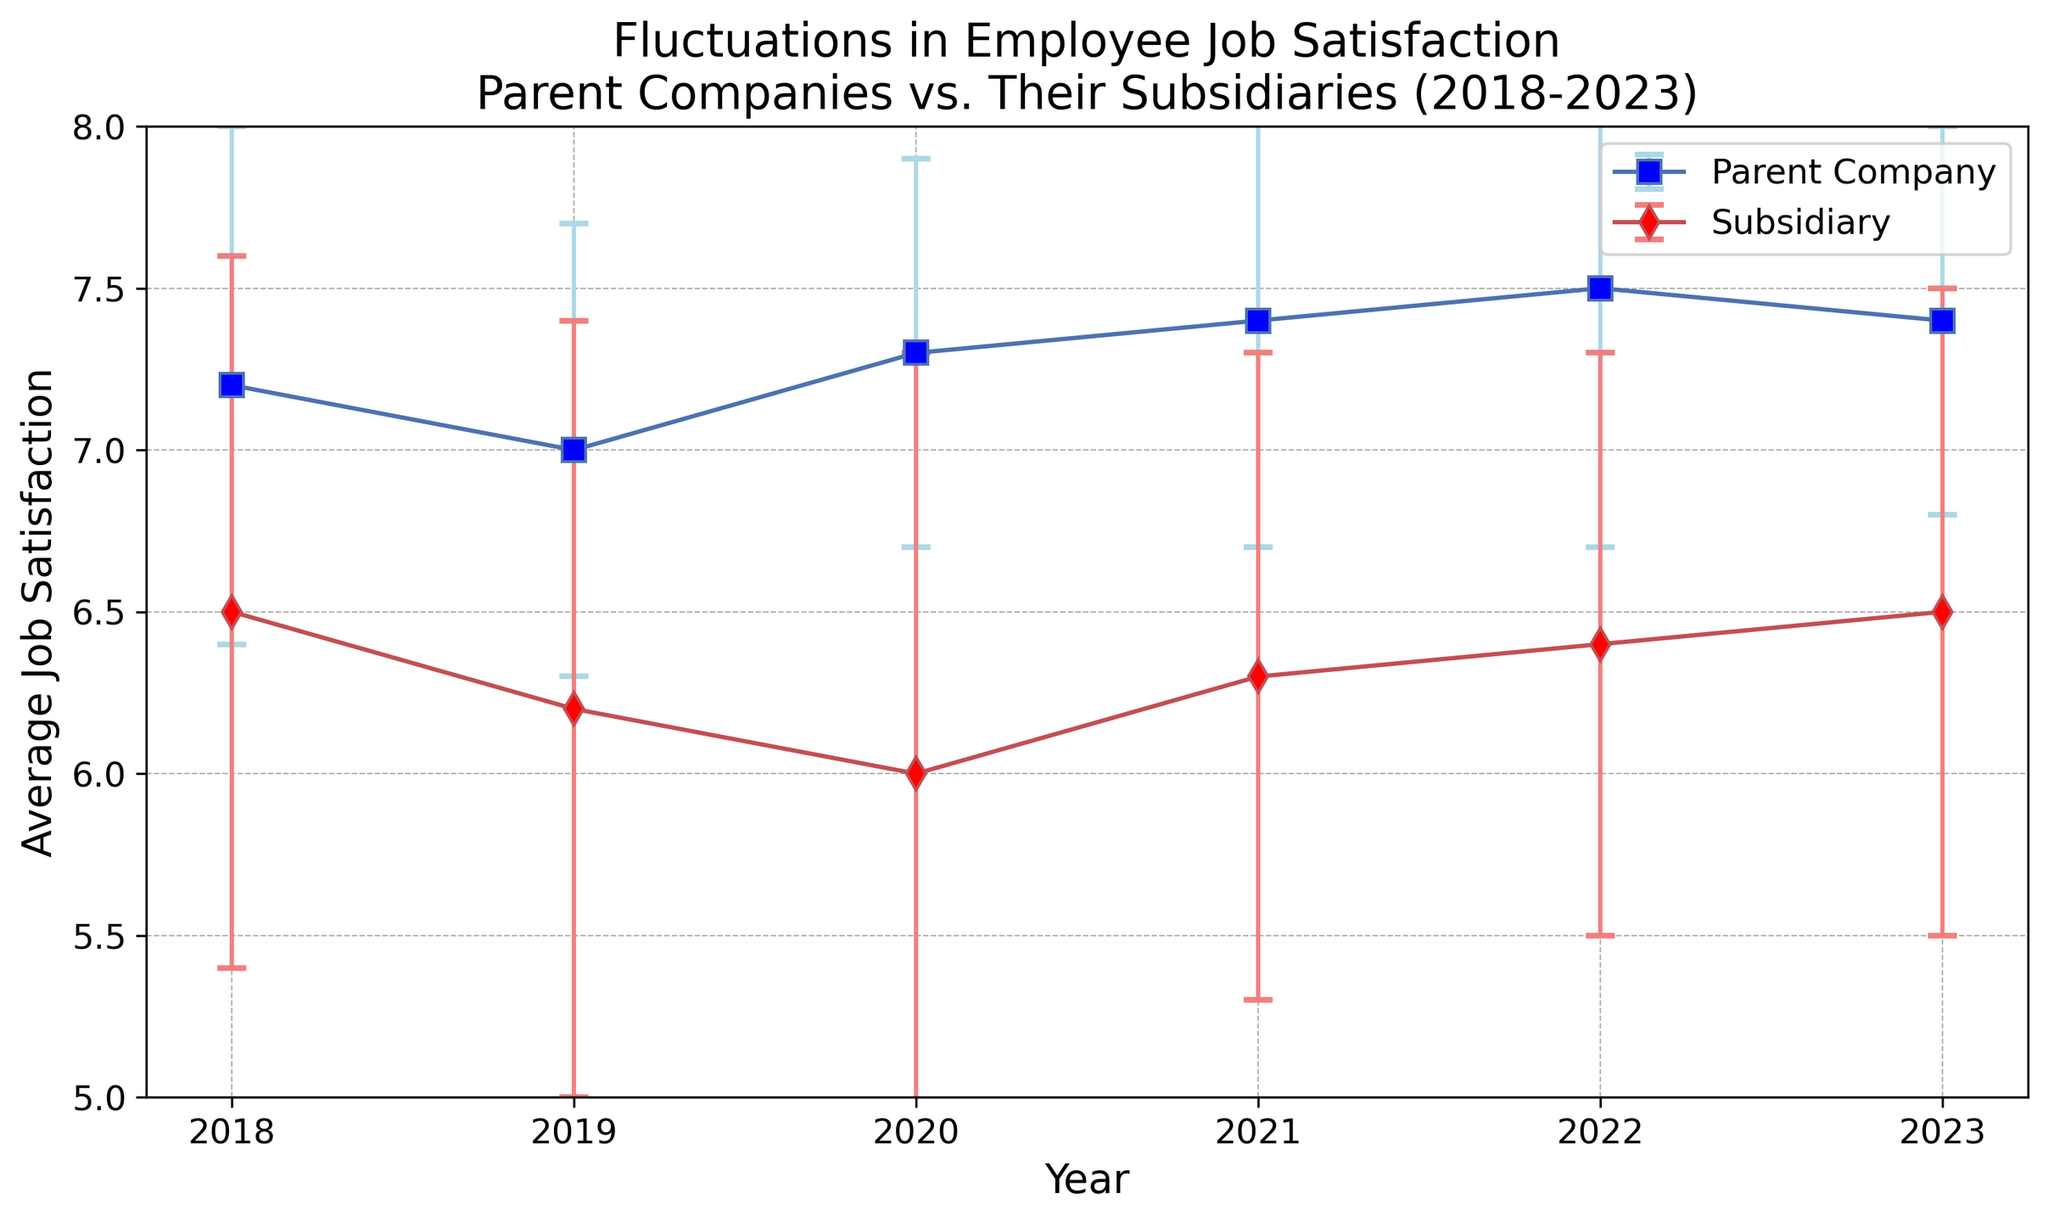What year shows the highest average job satisfaction for the parent companies? We need to look at the graph and identify the year with the highest data point for the parent company, which is represented by the blue markers. The year 2022 has the highest value.
Answer: 2022 How does the job satisfaction in subsidiaries change from 2018 to 2023? We need to compare the trend of job satisfaction in subsidiaries over the years. The graph shows that the job satisfaction for subsidiaries fluctuates but generally remains lower than that of parent companies, starting at 6.5 in 2018 and returning to 6.5 in 2023.
Answer: It fluctuates but remains lower What is the range of job satisfaction for the parent company in 2020? We look at the graph for the year 2020 and note the average and error bars for the parent company. The average is 7.3 and the standard deviation is 0.6, so the range is 7.3 - 0.6 to 7.3 + 0.6.
Answer: 6.7 to 7.9 In which year is the difference between parent and subsidiary job satisfaction the largest? We need to calculate the absolute differences between the two job satisfaction values for each year. 2020 has a parent satisfaction of 7.3 and subsidiary satisfaction of 6.0, making the difference 1.3, which is the largest.
Answer: 2020 Compare the error bars for the subsidiary data points in 2021 and 2022. Which year shows less variability? Error bars indicate the standard deviation. In 2021, the error bar is 1.0, while in 2022 it is 0.9. Smaller error bars indicate less variability.
Answer: 2022 What is the overall trend in job satisfaction for parent companies from 2018 to 2023? To find the trend, we examine the changes in job satisfaction values for the parent company across the years. The values generally increase slightly from 7.2 in 2018 to 7.4 in 2023.
Answer: Increasing Which company's employees generally have higher job satisfaction, parent or subsidiary? By comparing the overall trends of the two sets of data points, employees in parent companies consistently show higher job satisfaction than those in subsidiaries.
Answer: Parent What is the average job satisfaction for subsidiaries in 2018 and 2023? How do they compare? In 2018, the average is 6.5, and in 2023, it is also 6.5. Therefore, the average job satisfaction stayed the same.
Answer: They are equal What is the standard deviation of job satisfaction for subsidiaries in 2020? How does it affect the reliability of the average job satisfaction for that year? The standard deviation for subsidiaries in 2020 is 1.3. A high standard deviation means that there is more variability in the job satisfaction ratings, making the average less reliable as a precise indicator.
Answer: 1.3; less reliable 